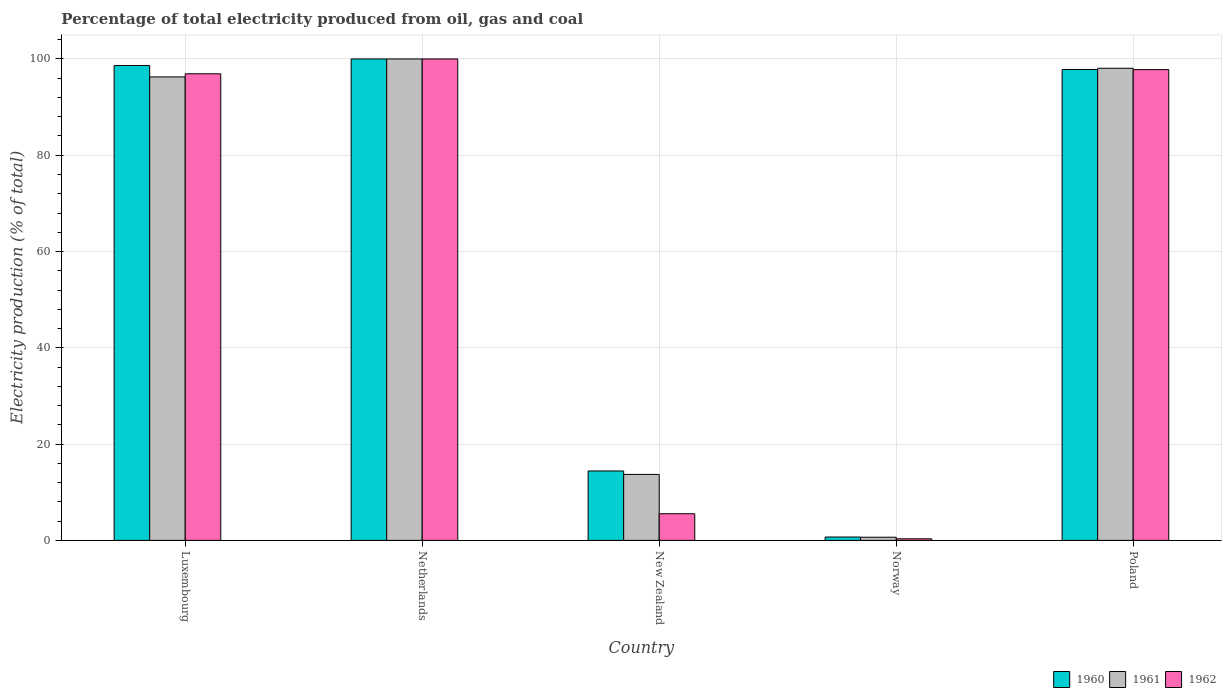How many different coloured bars are there?
Provide a short and direct response. 3. Are the number of bars on each tick of the X-axis equal?
Provide a short and direct response. Yes. How many bars are there on the 1st tick from the left?
Provide a succinct answer. 3. In how many cases, is the number of bars for a given country not equal to the number of legend labels?
Provide a succinct answer. 0. What is the electricity production in in 1962 in New Zealand?
Offer a very short reply. 5.54. Across all countries, what is the maximum electricity production in in 1961?
Offer a very short reply. 100. Across all countries, what is the minimum electricity production in in 1961?
Give a very brief answer. 0.66. In which country was the electricity production in in 1962 maximum?
Your answer should be very brief. Netherlands. What is the total electricity production in in 1961 in the graph?
Provide a succinct answer. 308.7. What is the difference between the electricity production in in 1962 in Netherlands and that in Norway?
Your answer should be compact. 99.67. What is the difference between the electricity production in in 1960 in Netherlands and the electricity production in in 1962 in Poland?
Offer a terse response. 2.21. What is the average electricity production in in 1960 per country?
Give a very brief answer. 62.31. What is the difference between the electricity production in of/in 1962 and electricity production in of/in 1961 in Poland?
Offer a terse response. -0.28. In how many countries, is the electricity production in in 1960 greater than 32 %?
Your answer should be very brief. 3. What is the ratio of the electricity production in in 1960 in Norway to that in Poland?
Provide a succinct answer. 0.01. Is the difference between the electricity production in in 1962 in Luxembourg and New Zealand greater than the difference between the electricity production in in 1961 in Luxembourg and New Zealand?
Your answer should be very brief. Yes. What is the difference between the highest and the second highest electricity production in in 1962?
Your answer should be very brief. -0.87. What is the difference between the highest and the lowest electricity production in in 1961?
Offer a very short reply. 99.34. In how many countries, is the electricity production in in 1962 greater than the average electricity production in in 1962 taken over all countries?
Ensure brevity in your answer.  3. What does the 2nd bar from the left in Netherlands represents?
Your answer should be compact. 1961. Are all the bars in the graph horizontal?
Keep it short and to the point. No. How many countries are there in the graph?
Keep it short and to the point. 5. What is the difference between two consecutive major ticks on the Y-axis?
Your answer should be very brief. 20. Does the graph contain grids?
Your response must be concise. Yes. How many legend labels are there?
Your answer should be very brief. 3. How are the legend labels stacked?
Provide a short and direct response. Horizontal. What is the title of the graph?
Give a very brief answer. Percentage of total electricity produced from oil, gas and coal. Does "1990" appear as one of the legend labels in the graph?
Make the answer very short. No. What is the label or title of the Y-axis?
Provide a short and direct response. Electricity production (% of total). What is the Electricity production (% of total) in 1960 in Luxembourg?
Your answer should be compact. 98.63. What is the Electricity production (% of total) of 1961 in Luxembourg?
Provide a short and direct response. 96.27. What is the Electricity production (% of total) of 1962 in Luxembourg?
Your response must be concise. 96.92. What is the Electricity production (% of total) of 1960 in Netherlands?
Offer a terse response. 100. What is the Electricity production (% of total) in 1962 in Netherlands?
Your answer should be compact. 100. What is the Electricity production (% of total) in 1960 in New Zealand?
Offer a terse response. 14.42. What is the Electricity production (% of total) in 1961 in New Zealand?
Make the answer very short. 13.71. What is the Electricity production (% of total) of 1962 in New Zealand?
Offer a terse response. 5.54. What is the Electricity production (% of total) of 1960 in Norway?
Offer a very short reply. 0.7. What is the Electricity production (% of total) of 1961 in Norway?
Give a very brief answer. 0.66. What is the Electricity production (% of total) of 1962 in Norway?
Provide a short and direct response. 0.33. What is the Electricity production (% of total) in 1960 in Poland?
Make the answer very short. 97.8. What is the Electricity production (% of total) of 1961 in Poland?
Your answer should be very brief. 98.07. What is the Electricity production (% of total) of 1962 in Poland?
Provide a succinct answer. 97.79. Across all countries, what is the maximum Electricity production (% of total) in 1960?
Provide a short and direct response. 100. Across all countries, what is the maximum Electricity production (% of total) in 1962?
Make the answer very short. 100. Across all countries, what is the minimum Electricity production (% of total) of 1960?
Your answer should be compact. 0.7. Across all countries, what is the minimum Electricity production (% of total) in 1961?
Keep it short and to the point. 0.66. Across all countries, what is the minimum Electricity production (% of total) in 1962?
Make the answer very short. 0.33. What is the total Electricity production (% of total) of 1960 in the graph?
Offer a terse response. 311.55. What is the total Electricity production (% of total) in 1961 in the graph?
Keep it short and to the point. 308.7. What is the total Electricity production (% of total) of 1962 in the graph?
Make the answer very short. 300.57. What is the difference between the Electricity production (% of total) of 1960 in Luxembourg and that in Netherlands?
Offer a very short reply. -1.37. What is the difference between the Electricity production (% of total) in 1961 in Luxembourg and that in Netherlands?
Your answer should be very brief. -3.73. What is the difference between the Electricity production (% of total) of 1962 in Luxembourg and that in Netherlands?
Offer a terse response. -3.08. What is the difference between the Electricity production (% of total) of 1960 in Luxembourg and that in New Zealand?
Offer a very short reply. 84.22. What is the difference between the Electricity production (% of total) of 1961 in Luxembourg and that in New Zealand?
Your answer should be very brief. 82.56. What is the difference between the Electricity production (% of total) of 1962 in Luxembourg and that in New Zealand?
Your response must be concise. 91.38. What is the difference between the Electricity production (% of total) of 1960 in Luxembourg and that in Norway?
Offer a very short reply. 97.93. What is the difference between the Electricity production (% of total) of 1961 in Luxembourg and that in Norway?
Offer a very short reply. 95.61. What is the difference between the Electricity production (% of total) of 1962 in Luxembourg and that in Norway?
Ensure brevity in your answer.  96.59. What is the difference between the Electricity production (% of total) of 1960 in Luxembourg and that in Poland?
Provide a succinct answer. 0.83. What is the difference between the Electricity production (% of total) in 1961 in Luxembourg and that in Poland?
Ensure brevity in your answer.  -1.8. What is the difference between the Electricity production (% of total) of 1962 in Luxembourg and that in Poland?
Your response must be concise. -0.87. What is the difference between the Electricity production (% of total) of 1960 in Netherlands and that in New Zealand?
Your answer should be very brief. 85.58. What is the difference between the Electricity production (% of total) in 1961 in Netherlands and that in New Zealand?
Your answer should be very brief. 86.29. What is the difference between the Electricity production (% of total) of 1962 in Netherlands and that in New Zealand?
Your answer should be very brief. 94.46. What is the difference between the Electricity production (% of total) in 1960 in Netherlands and that in Norway?
Your response must be concise. 99.3. What is the difference between the Electricity production (% of total) of 1961 in Netherlands and that in Norway?
Your answer should be very brief. 99.34. What is the difference between the Electricity production (% of total) of 1962 in Netherlands and that in Norway?
Offer a very short reply. 99.67. What is the difference between the Electricity production (% of total) in 1960 in Netherlands and that in Poland?
Provide a succinct answer. 2.2. What is the difference between the Electricity production (% of total) in 1961 in Netherlands and that in Poland?
Your answer should be very brief. 1.93. What is the difference between the Electricity production (% of total) of 1962 in Netherlands and that in Poland?
Your response must be concise. 2.21. What is the difference between the Electricity production (% of total) of 1960 in New Zealand and that in Norway?
Your answer should be very brief. 13.72. What is the difference between the Electricity production (% of total) in 1961 in New Zealand and that in Norway?
Give a very brief answer. 13.05. What is the difference between the Electricity production (% of total) in 1962 in New Zealand and that in Norway?
Provide a short and direct response. 5.21. What is the difference between the Electricity production (% of total) of 1960 in New Zealand and that in Poland?
Your answer should be very brief. -83.38. What is the difference between the Electricity production (% of total) in 1961 in New Zealand and that in Poland?
Give a very brief answer. -84.36. What is the difference between the Electricity production (% of total) of 1962 in New Zealand and that in Poland?
Offer a terse response. -92.25. What is the difference between the Electricity production (% of total) in 1960 in Norway and that in Poland?
Offer a terse response. -97.1. What is the difference between the Electricity production (% of total) in 1961 in Norway and that in Poland?
Make the answer very short. -97.41. What is the difference between the Electricity production (% of total) of 1962 in Norway and that in Poland?
Provide a succinct answer. -97.46. What is the difference between the Electricity production (% of total) in 1960 in Luxembourg and the Electricity production (% of total) in 1961 in Netherlands?
Provide a succinct answer. -1.37. What is the difference between the Electricity production (% of total) in 1960 in Luxembourg and the Electricity production (% of total) in 1962 in Netherlands?
Offer a very short reply. -1.37. What is the difference between the Electricity production (% of total) of 1961 in Luxembourg and the Electricity production (% of total) of 1962 in Netherlands?
Offer a terse response. -3.73. What is the difference between the Electricity production (% of total) in 1960 in Luxembourg and the Electricity production (% of total) in 1961 in New Zealand?
Provide a succinct answer. 84.93. What is the difference between the Electricity production (% of total) of 1960 in Luxembourg and the Electricity production (% of total) of 1962 in New Zealand?
Make the answer very short. 93.1. What is the difference between the Electricity production (% of total) in 1961 in Luxembourg and the Electricity production (% of total) in 1962 in New Zealand?
Offer a very short reply. 90.73. What is the difference between the Electricity production (% of total) in 1960 in Luxembourg and the Electricity production (% of total) in 1961 in Norway?
Make the answer very short. 97.98. What is the difference between the Electricity production (% of total) of 1960 in Luxembourg and the Electricity production (% of total) of 1962 in Norway?
Give a very brief answer. 98.3. What is the difference between the Electricity production (% of total) in 1961 in Luxembourg and the Electricity production (% of total) in 1962 in Norway?
Your response must be concise. 95.94. What is the difference between the Electricity production (% of total) in 1960 in Luxembourg and the Electricity production (% of total) in 1961 in Poland?
Your answer should be very brief. 0.57. What is the difference between the Electricity production (% of total) in 1960 in Luxembourg and the Electricity production (% of total) in 1962 in Poland?
Provide a succinct answer. 0.85. What is the difference between the Electricity production (% of total) in 1961 in Luxembourg and the Electricity production (% of total) in 1962 in Poland?
Make the answer very short. -1.52. What is the difference between the Electricity production (% of total) in 1960 in Netherlands and the Electricity production (% of total) in 1961 in New Zealand?
Ensure brevity in your answer.  86.29. What is the difference between the Electricity production (% of total) in 1960 in Netherlands and the Electricity production (% of total) in 1962 in New Zealand?
Offer a very short reply. 94.46. What is the difference between the Electricity production (% of total) of 1961 in Netherlands and the Electricity production (% of total) of 1962 in New Zealand?
Offer a very short reply. 94.46. What is the difference between the Electricity production (% of total) in 1960 in Netherlands and the Electricity production (% of total) in 1961 in Norway?
Offer a very short reply. 99.34. What is the difference between the Electricity production (% of total) in 1960 in Netherlands and the Electricity production (% of total) in 1962 in Norway?
Ensure brevity in your answer.  99.67. What is the difference between the Electricity production (% of total) of 1961 in Netherlands and the Electricity production (% of total) of 1962 in Norway?
Give a very brief answer. 99.67. What is the difference between the Electricity production (% of total) of 1960 in Netherlands and the Electricity production (% of total) of 1961 in Poland?
Provide a short and direct response. 1.93. What is the difference between the Electricity production (% of total) of 1960 in Netherlands and the Electricity production (% of total) of 1962 in Poland?
Ensure brevity in your answer.  2.21. What is the difference between the Electricity production (% of total) of 1961 in Netherlands and the Electricity production (% of total) of 1962 in Poland?
Provide a succinct answer. 2.21. What is the difference between the Electricity production (% of total) in 1960 in New Zealand and the Electricity production (% of total) in 1961 in Norway?
Make the answer very short. 13.76. What is the difference between the Electricity production (% of total) in 1960 in New Zealand and the Electricity production (% of total) in 1962 in Norway?
Provide a succinct answer. 14.09. What is the difference between the Electricity production (% of total) in 1961 in New Zealand and the Electricity production (% of total) in 1962 in Norway?
Ensure brevity in your answer.  13.38. What is the difference between the Electricity production (% of total) in 1960 in New Zealand and the Electricity production (% of total) in 1961 in Poland?
Provide a short and direct response. -83.65. What is the difference between the Electricity production (% of total) of 1960 in New Zealand and the Electricity production (% of total) of 1962 in Poland?
Give a very brief answer. -83.37. What is the difference between the Electricity production (% of total) of 1961 in New Zealand and the Electricity production (% of total) of 1962 in Poland?
Provide a succinct answer. -84.08. What is the difference between the Electricity production (% of total) in 1960 in Norway and the Electricity production (% of total) in 1961 in Poland?
Your answer should be compact. -97.37. What is the difference between the Electricity production (% of total) in 1960 in Norway and the Electricity production (% of total) in 1962 in Poland?
Keep it short and to the point. -97.09. What is the difference between the Electricity production (% of total) of 1961 in Norway and the Electricity production (% of total) of 1962 in Poland?
Provide a short and direct response. -97.13. What is the average Electricity production (% of total) in 1960 per country?
Your answer should be compact. 62.31. What is the average Electricity production (% of total) of 1961 per country?
Keep it short and to the point. 61.74. What is the average Electricity production (% of total) of 1962 per country?
Offer a terse response. 60.11. What is the difference between the Electricity production (% of total) in 1960 and Electricity production (% of total) in 1961 in Luxembourg?
Provide a short and direct response. 2.36. What is the difference between the Electricity production (% of total) in 1960 and Electricity production (% of total) in 1962 in Luxembourg?
Your response must be concise. 1.72. What is the difference between the Electricity production (% of total) of 1961 and Electricity production (% of total) of 1962 in Luxembourg?
Provide a short and direct response. -0.65. What is the difference between the Electricity production (% of total) in 1960 and Electricity production (% of total) in 1962 in Netherlands?
Make the answer very short. 0. What is the difference between the Electricity production (% of total) in 1961 and Electricity production (% of total) in 1962 in Netherlands?
Make the answer very short. 0. What is the difference between the Electricity production (% of total) in 1960 and Electricity production (% of total) in 1961 in New Zealand?
Ensure brevity in your answer.  0.71. What is the difference between the Electricity production (% of total) of 1960 and Electricity production (% of total) of 1962 in New Zealand?
Provide a succinct answer. 8.88. What is the difference between the Electricity production (% of total) of 1961 and Electricity production (% of total) of 1962 in New Zealand?
Provide a short and direct response. 8.17. What is the difference between the Electricity production (% of total) in 1960 and Electricity production (% of total) in 1961 in Norway?
Make the answer very short. 0.04. What is the difference between the Electricity production (% of total) in 1960 and Electricity production (% of total) in 1962 in Norway?
Give a very brief answer. 0.37. What is the difference between the Electricity production (% of total) of 1961 and Electricity production (% of total) of 1962 in Norway?
Your response must be concise. 0.33. What is the difference between the Electricity production (% of total) of 1960 and Electricity production (% of total) of 1961 in Poland?
Make the answer very short. -0.27. What is the difference between the Electricity production (% of total) of 1960 and Electricity production (% of total) of 1962 in Poland?
Offer a terse response. 0.01. What is the difference between the Electricity production (% of total) in 1961 and Electricity production (% of total) in 1962 in Poland?
Your answer should be very brief. 0.28. What is the ratio of the Electricity production (% of total) in 1960 in Luxembourg to that in Netherlands?
Keep it short and to the point. 0.99. What is the ratio of the Electricity production (% of total) in 1961 in Luxembourg to that in Netherlands?
Keep it short and to the point. 0.96. What is the ratio of the Electricity production (% of total) of 1962 in Luxembourg to that in Netherlands?
Give a very brief answer. 0.97. What is the ratio of the Electricity production (% of total) of 1960 in Luxembourg to that in New Zealand?
Provide a succinct answer. 6.84. What is the ratio of the Electricity production (% of total) of 1961 in Luxembourg to that in New Zealand?
Offer a very short reply. 7.02. What is the ratio of the Electricity production (% of total) of 1962 in Luxembourg to that in New Zealand?
Make the answer very short. 17.51. What is the ratio of the Electricity production (% of total) in 1960 in Luxembourg to that in Norway?
Keep it short and to the point. 140.97. What is the ratio of the Electricity production (% of total) in 1961 in Luxembourg to that in Norway?
Your answer should be compact. 146.53. What is the ratio of the Electricity production (% of total) of 1962 in Luxembourg to that in Norway?
Provide a short and direct response. 293.27. What is the ratio of the Electricity production (% of total) of 1960 in Luxembourg to that in Poland?
Your answer should be very brief. 1.01. What is the ratio of the Electricity production (% of total) of 1961 in Luxembourg to that in Poland?
Provide a short and direct response. 0.98. What is the ratio of the Electricity production (% of total) of 1960 in Netherlands to that in New Zealand?
Give a very brief answer. 6.94. What is the ratio of the Electricity production (% of total) of 1961 in Netherlands to that in New Zealand?
Your response must be concise. 7.29. What is the ratio of the Electricity production (% of total) in 1962 in Netherlands to that in New Zealand?
Ensure brevity in your answer.  18.06. What is the ratio of the Electricity production (% of total) in 1960 in Netherlands to that in Norway?
Offer a very short reply. 142.93. What is the ratio of the Electricity production (% of total) of 1961 in Netherlands to that in Norway?
Provide a succinct answer. 152.21. What is the ratio of the Electricity production (% of total) of 1962 in Netherlands to that in Norway?
Make the answer very short. 302.6. What is the ratio of the Electricity production (% of total) in 1960 in Netherlands to that in Poland?
Your answer should be very brief. 1.02. What is the ratio of the Electricity production (% of total) of 1961 in Netherlands to that in Poland?
Keep it short and to the point. 1.02. What is the ratio of the Electricity production (% of total) in 1962 in Netherlands to that in Poland?
Provide a short and direct response. 1.02. What is the ratio of the Electricity production (% of total) in 1960 in New Zealand to that in Norway?
Provide a short and direct response. 20.61. What is the ratio of the Electricity production (% of total) in 1961 in New Zealand to that in Norway?
Make the answer very short. 20.87. What is the ratio of the Electricity production (% of total) of 1962 in New Zealand to that in Norway?
Your answer should be very brief. 16.75. What is the ratio of the Electricity production (% of total) in 1960 in New Zealand to that in Poland?
Offer a terse response. 0.15. What is the ratio of the Electricity production (% of total) of 1961 in New Zealand to that in Poland?
Offer a very short reply. 0.14. What is the ratio of the Electricity production (% of total) of 1962 in New Zealand to that in Poland?
Your answer should be very brief. 0.06. What is the ratio of the Electricity production (% of total) in 1960 in Norway to that in Poland?
Your answer should be very brief. 0.01. What is the ratio of the Electricity production (% of total) of 1961 in Norway to that in Poland?
Your answer should be very brief. 0.01. What is the ratio of the Electricity production (% of total) of 1962 in Norway to that in Poland?
Give a very brief answer. 0. What is the difference between the highest and the second highest Electricity production (% of total) in 1960?
Offer a terse response. 1.37. What is the difference between the highest and the second highest Electricity production (% of total) in 1961?
Ensure brevity in your answer.  1.93. What is the difference between the highest and the second highest Electricity production (% of total) of 1962?
Provide a succinct answer. 2.21. What is the difference between the highest and the lowest Electricity production (% of total) of 1960?
Your response must be concise. 99.3. What is the difference between the highest and the lowest Electricity production (% of total) of 1961?
Offer a very short reply. 99.34. What is the difference between the highest and the lowest Electricity production (% of total) in 1962?
Make the answer very short. 99.67. 